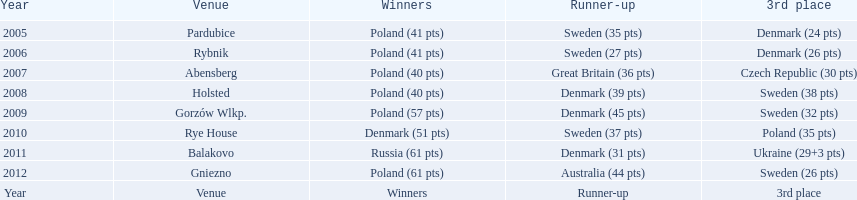After obtaining five straight victories at the team speedway junior world championship, poland was ultimately defeated in which year? 2010. In that particular year, which teams stood at the first, second, and third positions? Denmark (51 pts), Sweden (37 pts), Poland (35 pts). What was poland's precise position among those teams? 3rd place. 